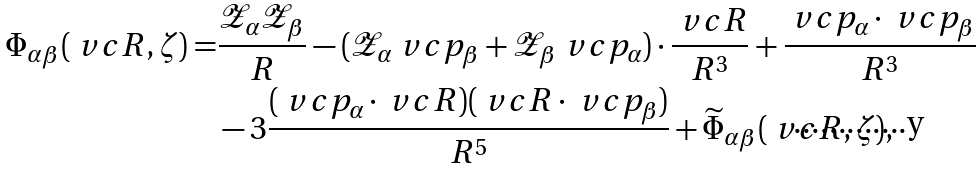Convert formula to latex. <formula><loc_0><loc_0><loc_500><loc_500>\Phi _ { \alpha \beta } ( \ v c { R } , \zeta ) = & \frac { \mathcal { Z } _ { \alpha } \mathcal { Z } _ { \beta } } { R } - ( \mathcal { Z } _ { \alpha } \ v c { p } _ { \beta } + \mathcal { Z } _ { \beta } \ v c { p } _ { \alpha } ) \cdot \frac { \ v c { R } } { R ^ { 3 } } + \frac { \ v c { p } _ { \alpha } \cdot \ v c { p } _ { \beta } } { R ^ { 3 } } \\ & - 3 \frac { ( \ v c { p } _ { \alpha } \cdot \ v c { R } ) ( \ v c { R } \cdot \ v c { p } _ { \beta } ) } { R ^ { 5 } } + \widetilde { \Phi } _ { \alpha \beta } ( \ v c { R } , \zeta ) ,</formula> 